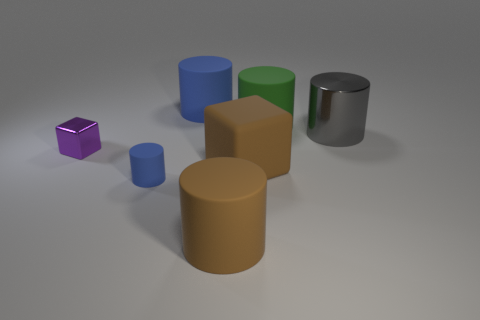Subtract all brown cylinders. How many cylinders are left? 4 Add 2 large green metallic things. How many objects exist? 9 Subtract all green cylinders. How many cylinders are left? 4 Subtract 1 blocks. How many blocks are left? 1 Subtract all gray spheres. How many blue cylinders are left? 2 Subtract all blocks. How many objects are left? 5 Add 3 big gray cylinders. How many big gray cylinders are left? 4 Add 5 blue objects. How many blue objects exist? 7 Subtract 0 green blocks. How many objects are left? 7 Subtract all cyan cylinders. Subtract all blue cubes. How many cylinders are left? 5 